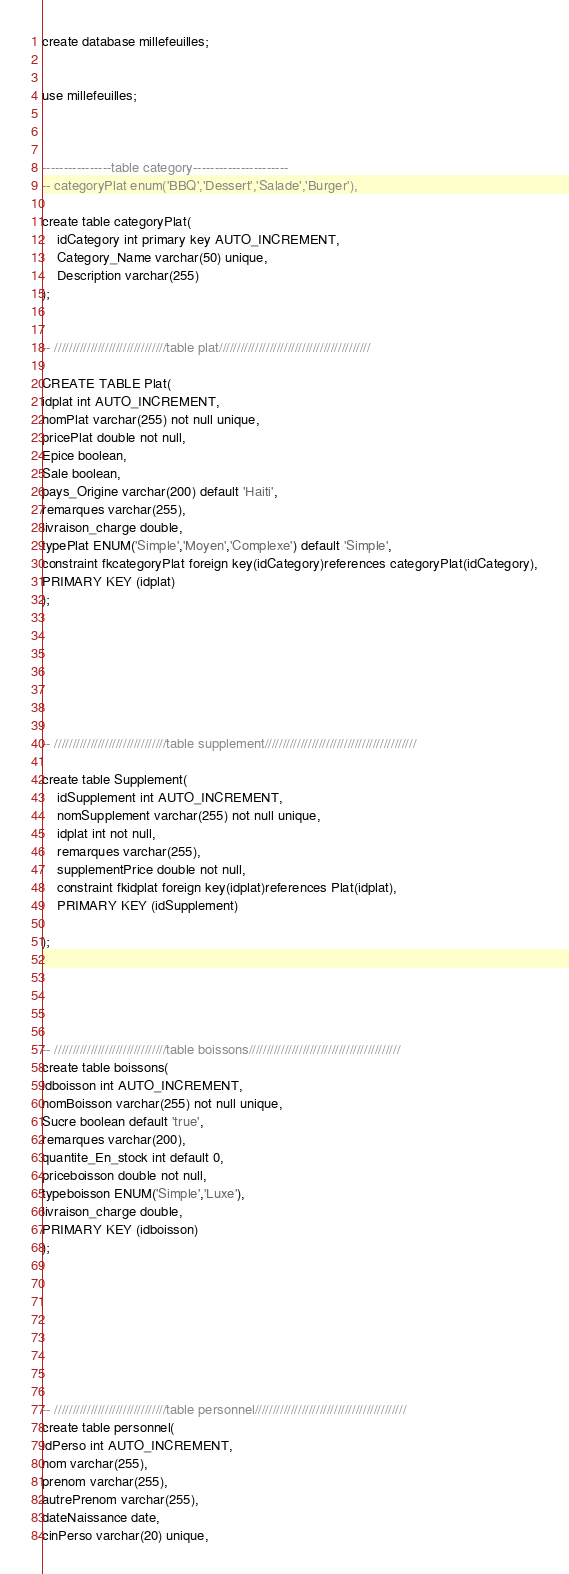Convert code to text. <code><loc_0><loc_0><loc_500><loc_500><_SQL_>
create database millefeuilles;


use millefeuilles;



----------------table category----------------------
-- categoryPlat enum('BBQ','Dessert','Salade','Burger'),

create table categoryPlat(
    idCategory int primary key AUTO_INCREMENT,
    Category_Name varchar(50) unique,
    Description varchar(255)
);


-- ///////////////////////////////table plat//////////////////////////////////////////

CREATE TABLE Plat( 
idplat int AUTO_INCREMENT, 
nomPlat varchar(255) not null unique,
pricePlat double not null,
Epice boolean,
Sale boolean,
pays_Origine varchar(200) default 'Haiti',
remarques varchar(255),
livraison_charge double,
typePlat ENUM('Simple','Moyen','Complexe') default 'Simple',
constraint fkcategoryPlat foreign key(idCategory)references categoryPlat(idCategory),
PRIMARY KEY (idplat)
);







-- ///////////////////////////////table supplement//////////////////////////////////////////

create table Supplement(
    idSupplement int AUTO_INCREMENT,
    nomSupplement varchar(255) not null unique,
    idplat int not null,
    remarques varchar(255),
    supplementPrice double not null,
    constraint fkidplat foreign key(idplat)references Plat(idplat),
    PRIMARY KEY (idSupplement)

);





-- ///////////////////////////////table boissons//////////////////////////////////////////
create table boissons(
idboisson int AUTO_INCREMENT, 
nomBoisson varchar(255) not null unique,
Sucre boolean default 'true',
remarques varchar(200),
quantite_En_stock int default 0,
priceboisson double not null,
typeboisson ENUM('Simple','Luxe'),
livraison_charge double,
PRIMARY KEY (idboisson)
);








-- ///////////////////////////////table personnel//////////////////////////////////////////
create table personnel(
idPerso int AUTO_INCREMENT,
nom varchar(255),
prenom varchar(255),
autrePrenom varchar(255),
dateNaissance date,
cinPerso varchar(20) unique,</code> 